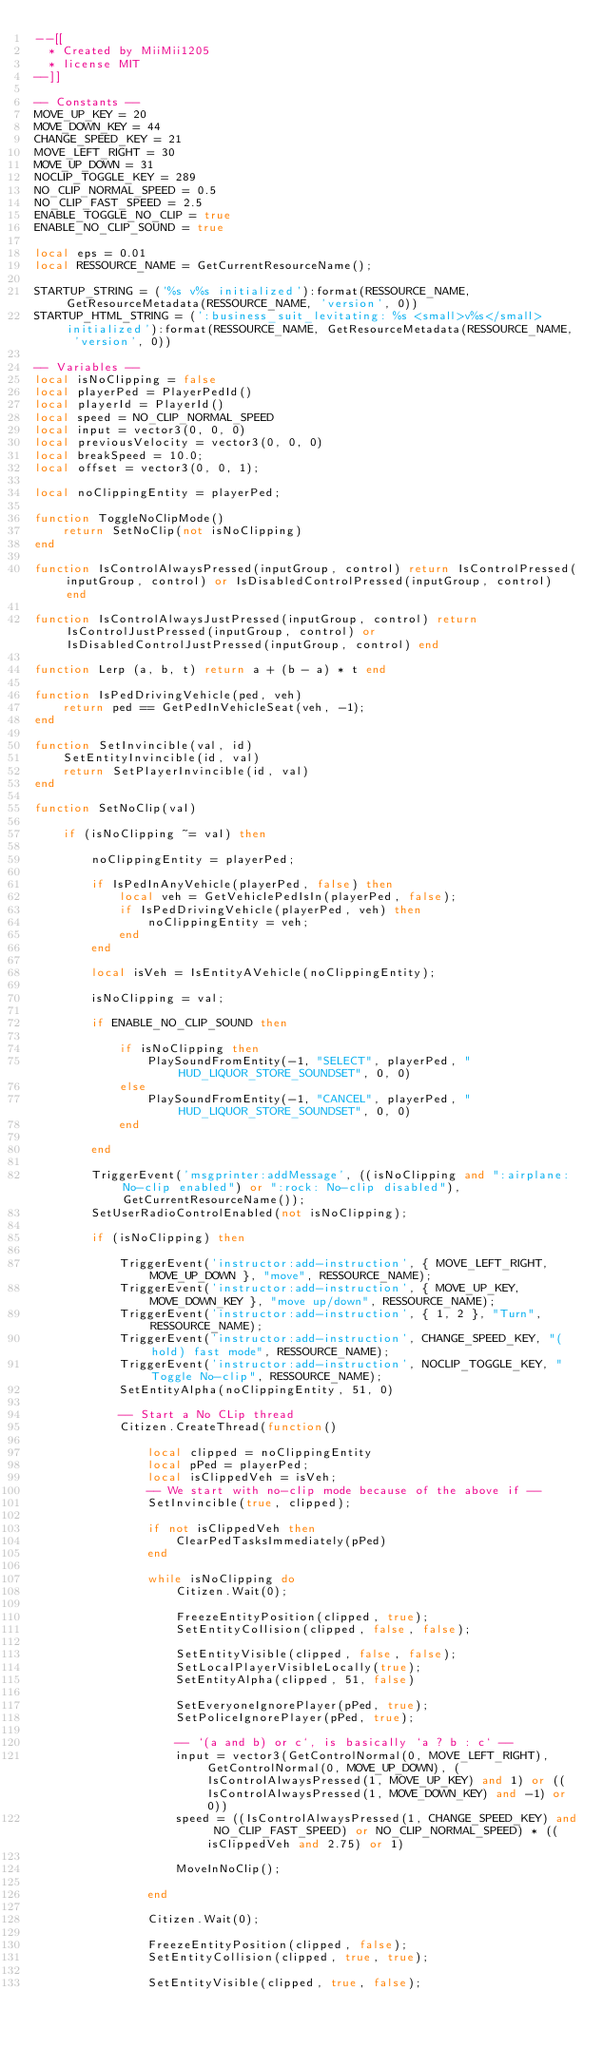<code> <loc_0><loc_0><loc_500><loc_500><_Lua_>--[[
  * Created by MiiMii1205
  * license MIT
--]]

-- Constants --
MOVE_UP_KEY = 20
MOVE_DOWN_KEY = 44
CHANGE_SPEED_KEY = 21
MOVE_LEFT_RIGHT = 30
MOVE_UP_DOWN = 31
NOCLIP_TOGGLE_KEY = 289
NO_CLIP_NORMAL_SPEED = 0.5
NO_CLIP_FAST_SPEED = 2.5
ENABLE_TOGGLE_NO_CLIP = true
ENABLE_NO_CLIP_SOUND = true

local eps = 0.01
local RESSOURCE_NAME = GetCurrentResourceName();

STARTUP_STRING = ('%s v%s initialized'):format(RESSOURCE_NAME, GetResourceMetadata(RESSOURCE_NAME, 'version', 0))
STARTUP_HTML_STRING = (':business_suit_levitating: %s <small>v%s</small> initialized'):format(RESSOURCE_NAME, GetResourceMetadata(RESSOURCE_NAME, 'version', 0))

-- Variables --
local isNoClipping = false
local playerPed = PlayerPedId()
local playerId = PlayerId()
local speed = NO_CLIP_NORMAL_SPEED
local input = vector3(0, 0, 0)
local previousVelocity = vector3(0, 0, 0)
local breakSpeed = 10.0;
local offset = vector3(0, 0, 1);

local noClippingEntity = playerPed;

function ToggleNoClipMode()
    return SetNoClip(not isNoClipping)
end

function IsControlAlwaysPressed(inputGroup, control) return IsControlPressed(inputGroup, control) or IsDisabledControlPressed(inputGroup, control) end

function IsControlAlwaysJustPressed(inputGroup, control) return IsControlJustPressed(inputGroup, control) or IsDisabledControlJustPressed(inputGroup, control) end

function Lerp (a, b, t) return a + (b - a) * t end

function IsPedDrivingVehicle(ped, veh)
    return ped == GetPedInVehicleSeat(veh, -1);
end

function SetInvincible(val, id)
    SetEntityInvincible(id, val)
    return SetPlayerInvincible(id, val)
end

function SetNoClip(val)

    if (isNoClipping ~= val) then

        noClippingEntity = playerPed;

        if IsPedInAnyVehicle(playerPed, false) then
            local veh = GetVehiclePedIsIn(playerPed, false);
            if IsPedDrivingVehicle(playerPed, veh) then
                noClippingEntity = veh;
            end
        end

        local isVeh = IsEntityAVehicle(noClippingEntity);

        isNoClipping = val;

        if ENABLE_NO_CLIP_SOUND then

            if isNoClipping then
                PlaySoundFromEntity(-1, "SELECT", playerPed, "HUD_LIQUOR_STORE_SOUNDSET", 0, 0)
            else
                PlaySoundFromEntity(-1, "CANCEL", playerPed, "HUD_LIQUOR_STORE_SOUNDSET", 0, 0)
            end

        end

        TriggerEvent('msgprinter:addMessage', ((isNoClipping and ":airplane: No-clip enabled") or ":rock: No-clip disabled"), GetCurrentResourceName());
        SetUserRadioControlEnabled(not isNoClipping);

        if (isNoClipping) then

            TriggerEvent('instructor:add-instruction', { MOVE_LEFT_RIGHT, MOVE_UP_DOWN }, "move", RESSOURCE_NAME);
            TriggerEvent('instructor:add-instruction', { MOVE_UP_KEY, MOVE_DOWN_KEY }, "move up/down", RESSOURCE_NAME);
            TriggerEvent('instructor:add-instruction', { 1, 2 }, "Turn", RESSOURCE_NAME);
            TriggerEvent('instructor:add-instruction', CHANGE_SPEED_KEY, "(hold) fast mode", RESSOURCE_NAME);
            TriggerEvent('instructor:add-instruction', NOCLIP_TOGGLE_KEY, "Toggle No-clip", RESSOURCE_NAME);
            SetEntityAlpha(noClippingEntity, 51, 0)

            -- Start a No CLip thread
            Citizen.CreateThread(function()

                local clipped = noClippingEntity
                local pPed = playerPed;
                local isClippedVeh = isVeh;
                -- We start with no-clip mode because of the above if --
                SetInvincible(true, clipped);

                if not isClippedVeh then
                    ClearPedTasksImmediately(pPed)
                end

                while isNoClipping do
                    Citizen.Wait(0);

                    FreezeEntityPosition(clipped, true);
                    SetEntityCollision(clipped, false, false);

                    SetEntityVisible(clipped, false, false);
                    SetLocalPlayerVisibleLocally(true);
                    SetEntityAlpha(clipped, 51, false)

                    SetEveryoneIgnorePlayer(pPed, true);
                    SetPoliceIgnorePlayer(pPed, true);

                    -- `(a and b) or c`, is basically `a ? b : c` --
                    input = vector3(GetControlNormal(0, MOVE_LEFT_RIGHT), GetControlNormal(0, MOVE_UP_DOWN), (IsControlAlwaysPressed(1, MOVE_UP_KEY) and 1) or ((IsControlAlwaysPressed(1, MOVE_DOWN_KEY) and -1) or 0))
                    speed = ((IsControlAlwaysPressed(1, CHANGE_SPEED_KEY) and NO_CLIP_FAST_SPEED) or NO_CLIP_NORMAL_SPEED) * ((isClippedVeh and 2.75) or 1)

                    MoveInNoClip();

                end

                Citizen.Wait(0);

                FreezeEntityPosition(clipped, false);
                SetEntityCollision(clipped, true, true);

                SetEntityVisible(clipped, true, false);</code> 